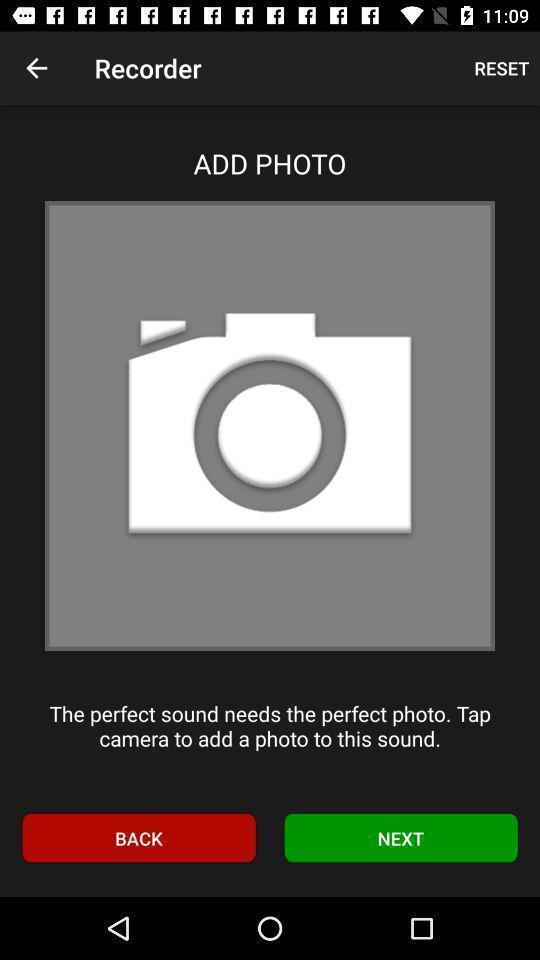Please provide a description for this image. Screen shows recorder page in noise application. 